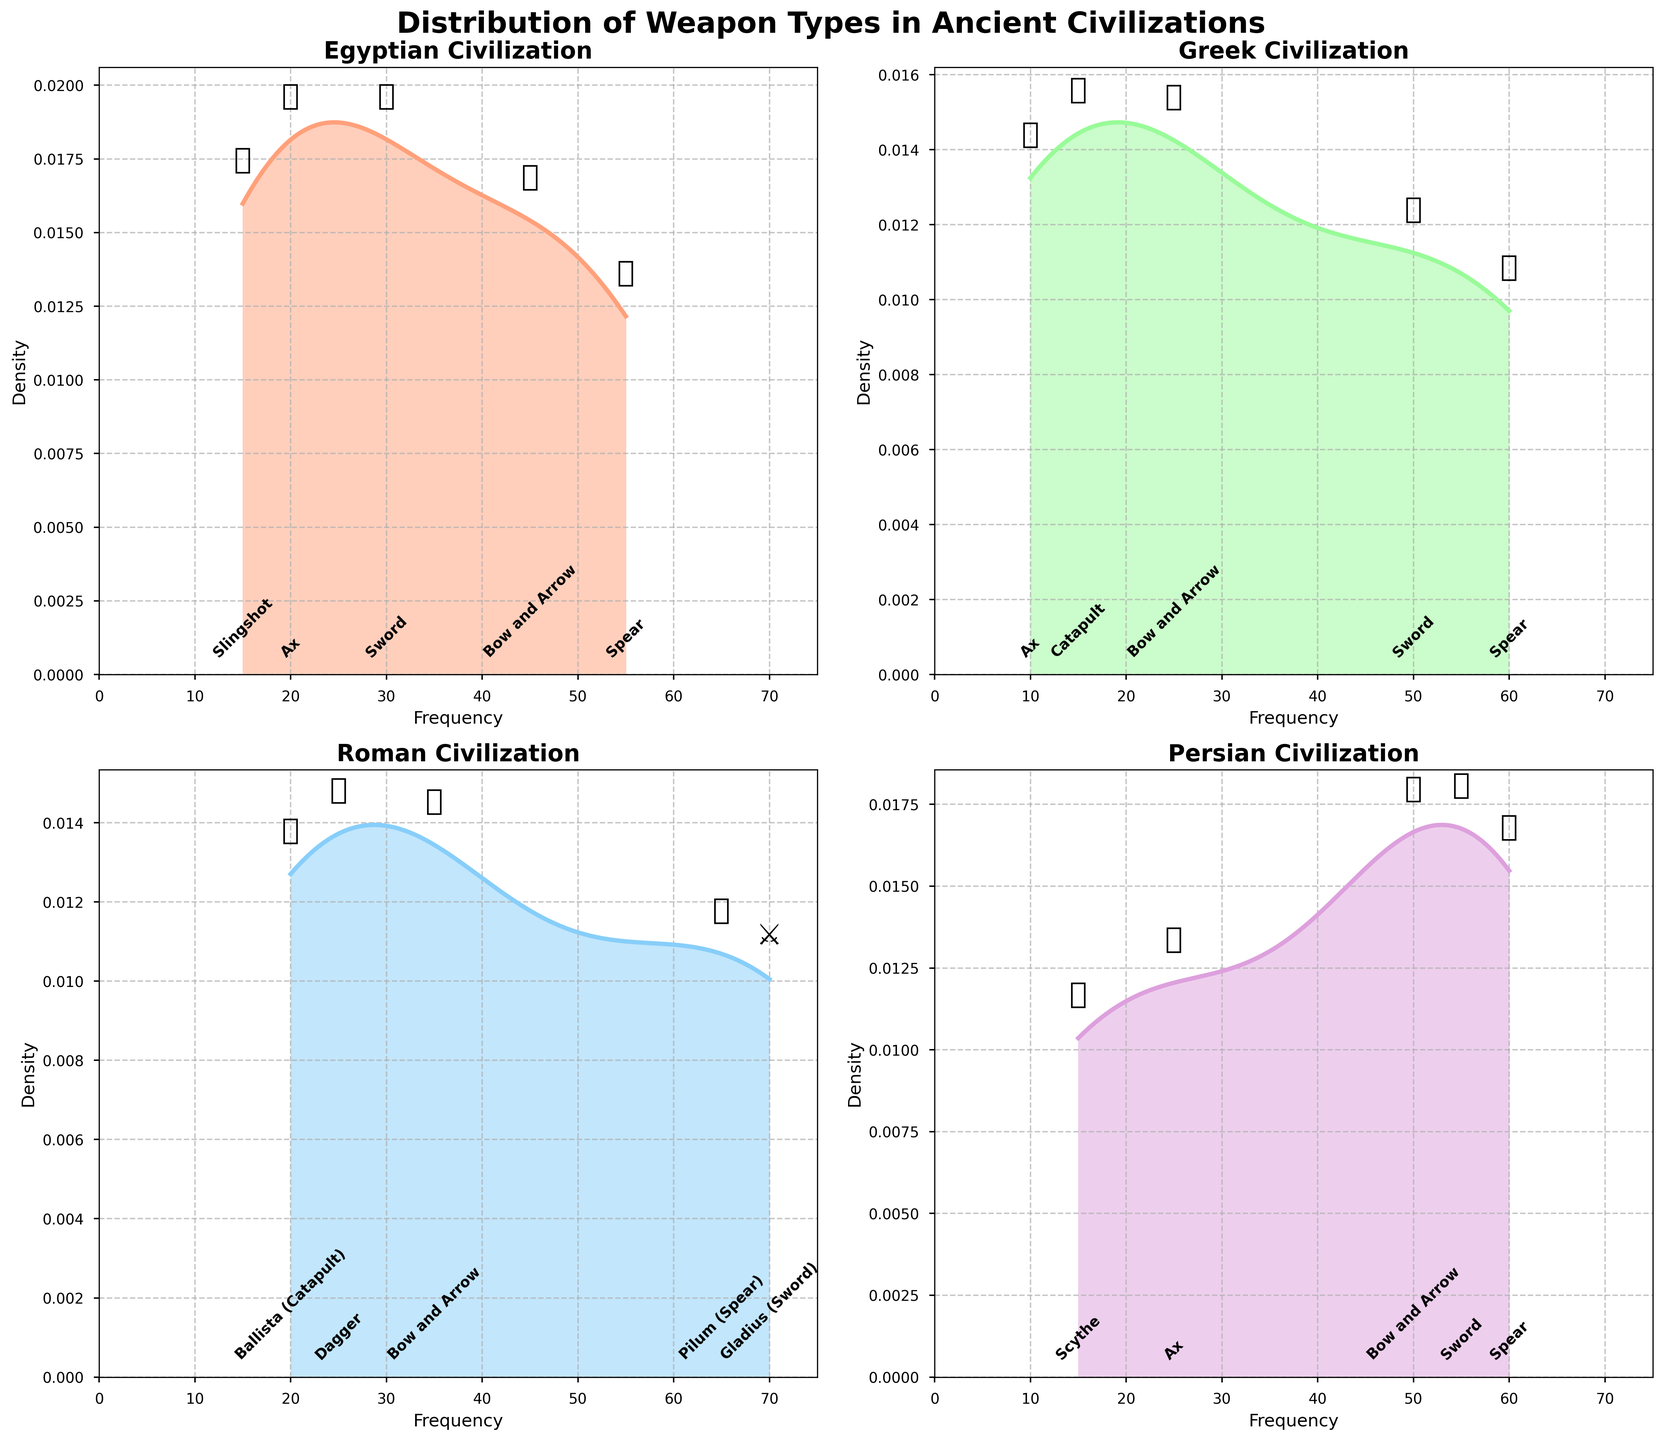What is the weapon type with the highest frequency in the Roman civilization? The Roman subplot shows that the weapon with the highest frequency is the Gladius (Sword), as indicated by its annotated point and density peak being to the far right.
Answer: Gladius (Sword) What is the range of weapon frequencies for the Egyptian civilization? In the Egyptian subplot, the frequencies range from the lowest point at 15 (for Slingshot) to the highest at 55 (for Spear).
Answer: 15 to 55 Which civilization has the widest range of weapon frequencies? Comparing the subplots, the Roman civilization has the widest range from 20 (Ballista) to 70 (Gladius), totaling a range of 50. This is more extensive than any other civilization shown.
Answer: Roman Between the Greek and Persian civilizations, which has a higher average weapon frequency? Compute the average for each: Greek frequencies are 50, 60, 25, 10, 15 which average to (50 + 60 + 25 + 10 + 15) / 5 = 32. Persian frequencies are 55, 60, 50, 25, 15 which average to (55 + 60 + 50 + 25 + 15) / 5 = 41. Persian has a higher average.
Answer: Persian How do the weapon type distributions in the Persian and Greek civilizations compare in terms of skewness? The Greek distribution centered around 50 to 60, and the Persian distribution around 50 to 60 also, but spread more, leaning towards lower values. The Greek distribution is more skewed towards higher frequencies compared to Persian.
Answer: Greek is more skewed towards higher frequencies Which civilization utilized slingshots? By checking annotations in each subplot, only the Egyptian civilization features the Slingshot annotation.
Answer: Egyptian What is the density peak value for the Persian civilization? Look at the Persian subplot; the density plot's peak value can be estimated close to the highest point on the y-axis when the x-axis is near 60.
Answer: Near 60 How do the densities of bow and arrow frequencies compare across the four civilizations? Inspecting each subplot, the Egyptian and Persian plots show bow and arrow with higher densities while Greek and Roman subplots show lower densities for the same.
Answer: Higher in Egyptian and Persian Which civilization has the fewest types of weapons represented? Counting annotations in each subplot, Greek and Roman show 5, while Egyptian and Persian show 6 different weapon types.
Answer: Greek What is the combined frequency of swords across all civilizations? Summing the sword frequencies: Egyptian (30) + Greek (50) + Roman (70 for Gladius, considered a sword) + Persian (55) equals 205.
Answer: 205 